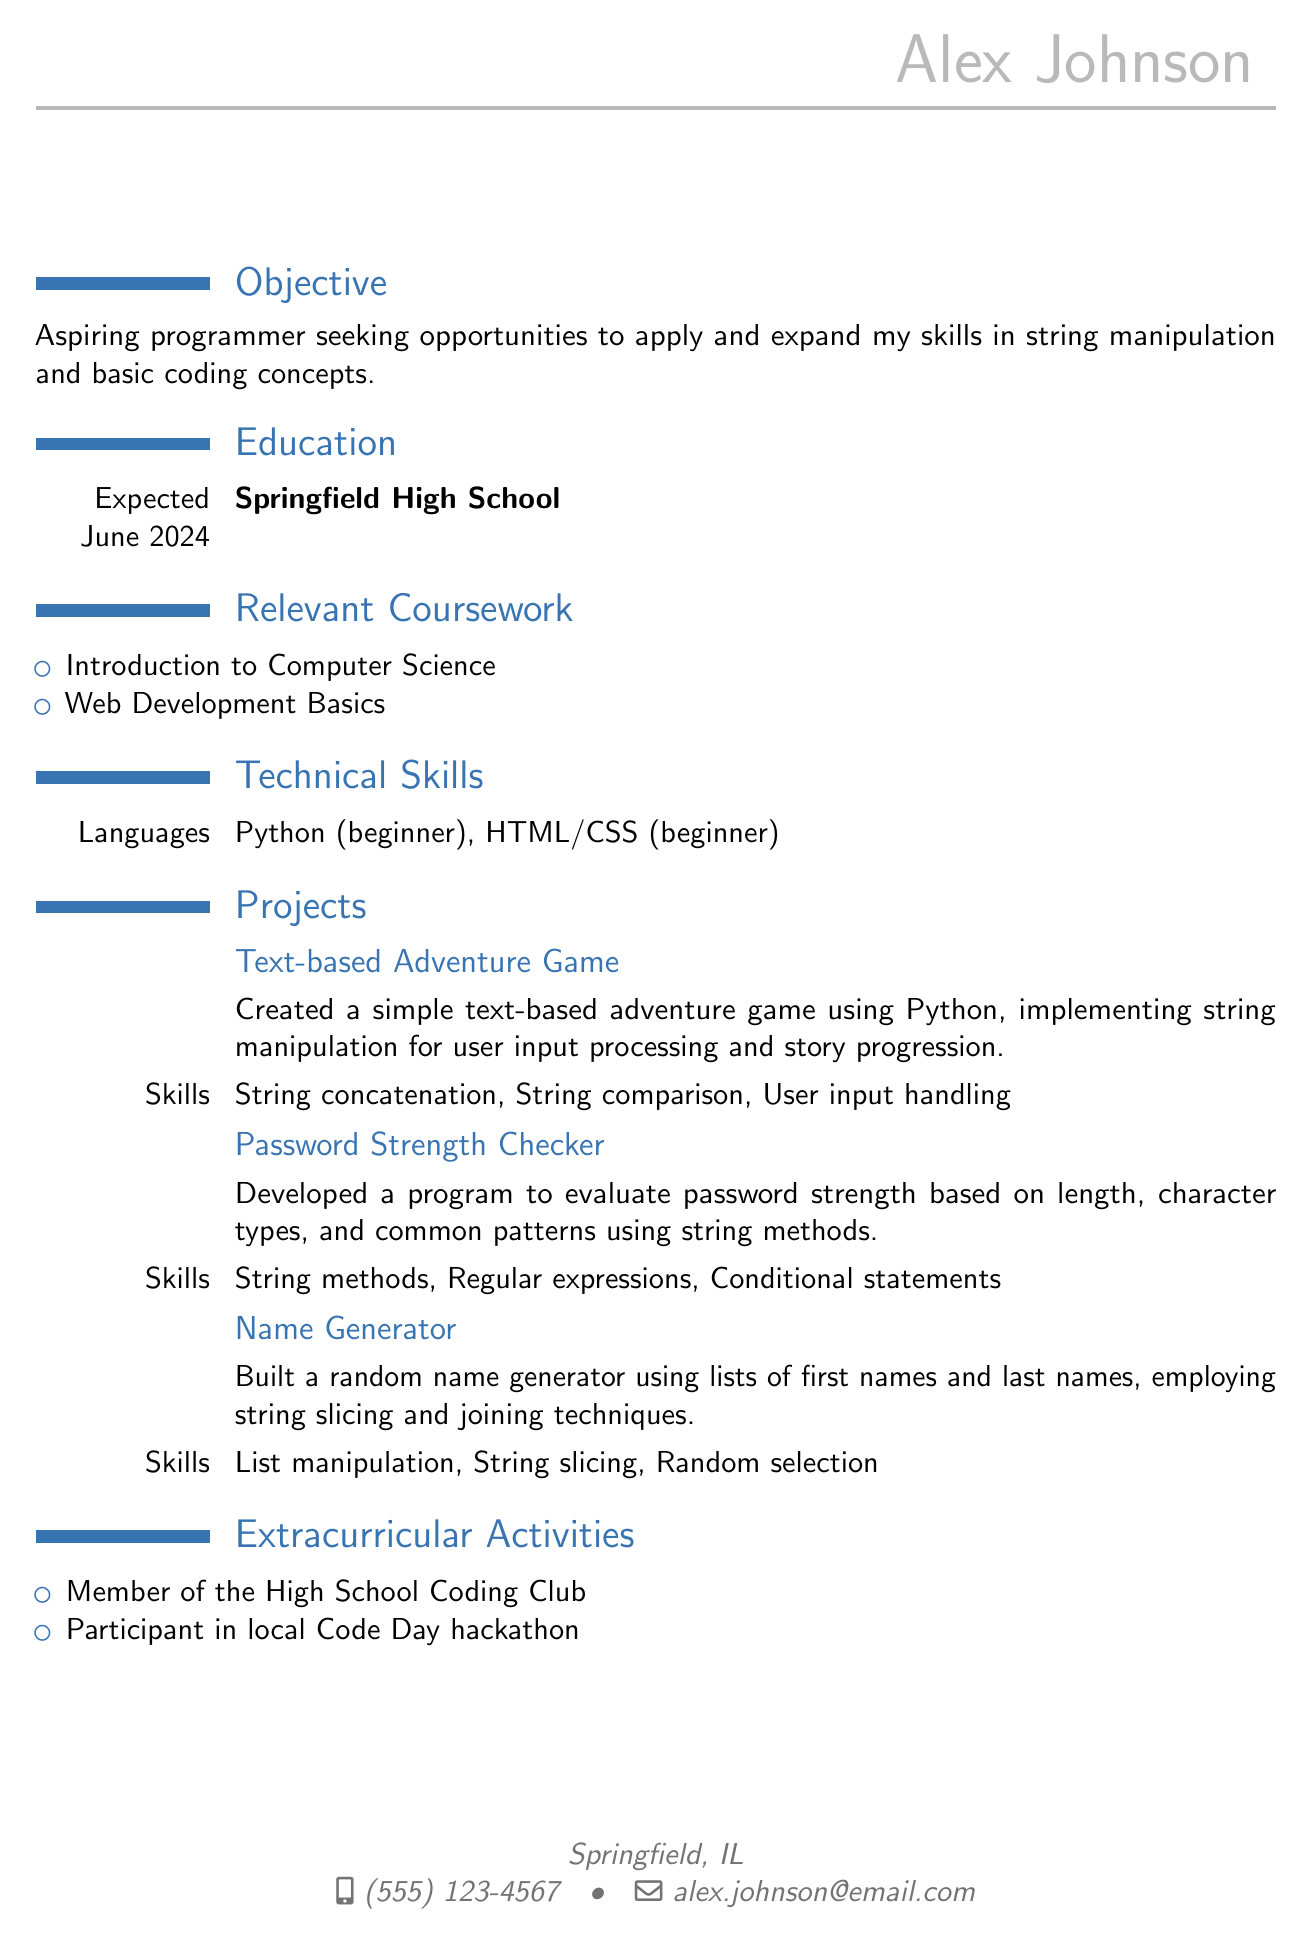What is the full name of the individual? The full name is provided in the personal information section of the document.
Answer: Alex Johnson What is the expected graduation date? The expected graduation date is listed in the education section of the document.
Answer: June 2024 Which programming language has a beginner level skill? The technical skills section includes programming languages and their skill levels.
Answer: Python What is the title of the first project mentioned? The document lists several projects with their names.
Answer: Text-based Adventure Game What skill is used in the Name Generator project? The skills section of the Name Generator project describes the techniques used.
Answer: String slicing How many extracurricular activities are listed? The total number of listed activities can be counted in the extracurricular activities section.
Answer: 2 What is the objective of the individual? The document explicitly states the individual's career objective.
Answer: Aspiring programmer seeking opportunities Which coding club is mentioned in the extracurricular activities? The extracurricular activities section lists clubs and events the individual participates in.
Answer: High School Coding Club 